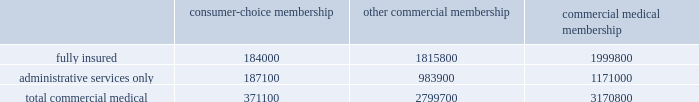Cost amount could have a material adverse effect on our business .
These changes may include , for example , an increase or reduction in the number of persons enrolled or eligible to enroll due to the federal government 2019s decision to increase or decrease u.s .
Military presence around the world .
In the event government reimbursements were to decline from projected amounts , our failure to reduce the health care costs associated with these programs could have a material adverse effect on our business .
During 2004 , we completed a contractual transition of our tricare business .
On july 1 , 2004 , our regions 2 and 5 contract servicing approximately 1.1 million tricare members became part of the new north region , which was awarded to another contractor .
On august 1 , 2004 , our regions 3 and 4 contract became part of our new south region contract .
On november 1 , 2004 , the region 6 contract with approximately 1 million members became part of the south region contract .
The members added with the region 6 contract essentially offset the members lost four months earlier with the expiration of our regions 2 and 5 contract .
For the year ended december 31 , 2005 , tricare premium revenues were approximately $ 2.4 billion , or 16.9% ( 16.9 % ) of our total premiums and aso fees .
Part of the tricare transition during 2004 included the carve out of the tricare senior pharmacy and tricare for life program which we previously administered on as aso basis .
On june 1 , 2004 and august 1 , 2004 , administrative services under these programs were transferred to another contractor .
For the year ended december 31 , 2005 , tricare administrative services fees totaled $ 50.1 million , or 0.4% ( 0.4 % ) of our total premiums and aso fees .
Our products marketed to commercial segment employers and members consumer-choice products over the last several years , we have developed and offered various commercial products designed to provide options and choices to employers that are annually facing substantial premium increases driven by double-digit medical cost inflation .
These consumer-choice products , which can be offered on either a fully insured or aso basis , provided coverage to approximately 371100 members at december 31 , 2005 , representing approximately 11.7% ( 11.7 % ) of our total commercial medical membership as detailed below .
Consumer-choice membership other commercial membership commercial medical membership .
These products are often offered to employer groups as 201cbundles 201d , where the subscribers are offered various hmo and ppo options , with various employer contribution strategies as determined by the employer .
Paramount to our consumer-choice product strategy , we have developed a group of innovative consumer products , styled as 201csmart 201d products , that we believe will be a long-term solution for employers .
We believe this new generation of products provides more ( 1 ) choices for the individual consumer , ( 2 ) transparency of provider costs , and ( 3 ) benefit designs that engage consumers in the costs and effectiveness of health care choices .
Innovative tools and technology are available to assist consumers with these decisions , including the trade-offs between higher premiums and point-of-service costs at the time consumers choose their plans , and to suggest ways in which the consumers can maximize their individual benefits at the point they use their plans .
We believe that when consumers can make informed choices about the cost and effectiveness of their health care , a sustainable long term solution for employers can be realized .
Smart products , which accounted for approximately 65.1% ( 65.1 % ) of enrollment in all of our consumer-choice plans as of december 31 , 2005 , only are sold to employers who use humana as their sole health insurance carrier. .
What is the value of the total premiums and aso fees , in billions? 
Rationale: considering the $ 50.1 million as 0.4% , the total 100% is calculated by multiplying the 50.1 by 100 , then dividing by 0.4 .
Computations: (((50.1 * 100) / 0.4) / 1000)
Answer: 12.525. Cost amount could have a material adverse effect on our business .
These changes may include , for example , an increase or reduction in the number of persons enrolled or eligible to enroll due to the federal government 2019s decision to increase or decrease u.s .
Military presence around the world .
In the event government reimbursements were to decline from projected amounts , our failure to reduce the health care costs associated with these programs could have a material adverse effect on our business .
During 2004 , we completed a contractual transition of our tricare business .
On july 1 , 2004 , our regions 2 and 5 contract servicing approximately 1.1 million tricare members became part of the new north region , which was awarded to another contractor .
On august 1 , 2004 , our regions 3 and 4 contract became part of our new south region contract .
On november 1 , 2004 , the region 6 contract with approximately 1 million members became part of the south region contract .
The members added with the region 6 contract essentially offset the members lost four months earlier with the expiration of our regions 2 and 5 contract .
For the year ended december 31 , 2005 , tricare premium revenues were approximately $ 2.4 billion , or 16.9% ( 16.9 % ) of our total premiums and aso fees .
Part of the tricare transition during 2004 included the carve out of the tricare senior pharmacy and tricare for life program which we previously administered on as aso basis .
On june 1 , 2004 and august 1 , 2004 , administrative services under these programs were transferred to another contractor .
For the year ended december 31 , 2005 , tricare administrative services fees totaled $ 50.1 million , or 0.4% ( 0.4 % ) of our total premiums and aso fees .
Our products marketed to commercial segment employers and members consumer-choice products over the last several years , we have developed and offered various commercial products designed to provide options and choices to employers that are annually facing substantial premium increases driven by double-digit medical cost inflation .
These consumer-choice products , which can be offered on either a fully insured or aso basis , provided coverage to approximately 371100 members at december 31 , 2005 , representing approximately 11.7% ( 11.7 % ) of our total commercial medical membership as detailed below .
Consumer-choice membership other commercial membership commercial medical membership .
These products are often offered to employer groups as 201cbundles 201d , where the subscribers are offered various hmo and ppo options , with various employer contribution strategies as determined by the employer .
Paramount to our consumer-choice product strategy , we have developed a group of innovative consumer products , styled as 201csmart 201d products , that we believe will be a long-term solution for employers .
We believe this new generation of products provides more ( 1 ) choices for the individual consumer , ( 2 ) transparency of provider costs , and ( 3 ) benefit designs that engage consumers in the costs and effectiveness of health care choices .
Innovative tools and technology are available to assist consumers with these decisions , including the trade-offs between higher premiums and point-of-service costs at the time consumers choose their plans , and to suggest ways in which the consumers can maximize their individual benefits at the point they use their plans .
We believe that when consumers can make informed choices about the cost and effectiveness of their health care , a sustainable long term solution for employers can be realized .
Smart products , which accounted for approximately 65.1% ( 65.1 % ) of enrollment in all of our consumer-choice plans as of december 31 , 2005 , only are sold to employers who use humana as their sole health insurance carrier. .
As of december 31 2005 what was the approximate number of total commercial medical membership? 
Computations: (371100 / 11.7%)
Answer: 3171794.87179. 